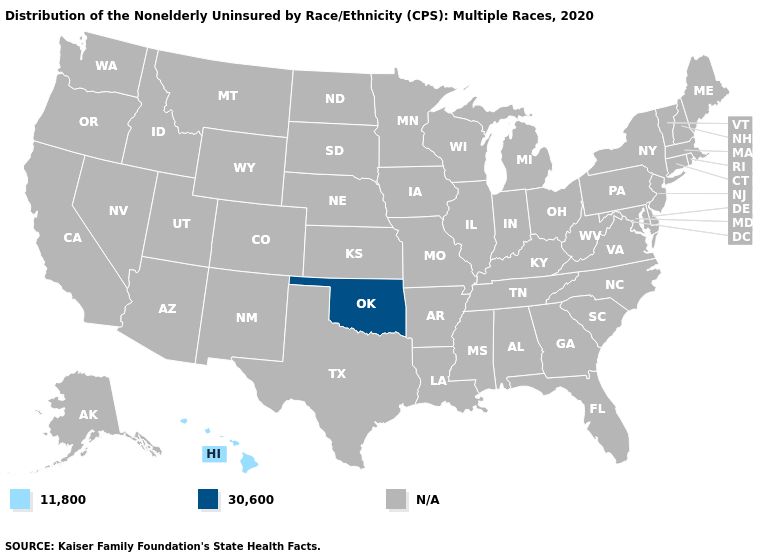Name the states that have a value in the range 30,600?
Give a very brief answer. Oklahoma. Does the map have missing data?
Concise answer only. Yes. Name the states that have a value in the range 30,600?
Concise answer only. Oklahoma. Name the states that have a value in the range 30,600?
Be succinct. Oklahoma. Name the states that have a value in the range 11,800?
Be succinct. Hawaii. Name the states that have a value in the range 30,600?
Write a very short answer. Oklahoma. Name the states that have a value in the range 30,600?
Quick response, please. Oklahoma. Name the states that have a value in the range N/A?
Answer briefly. Alabama, Alaska, Arizona, Arkansas, California, Colorado, Connecticut, Delaware, Florida, Georgia, Idaho, Illinois, Indiana, Iowa, Kansas, Kentucky, Louisiana, Maine, Maryland, Massachusetts, Michigan, Minnesota, Mississippi, Missouri, Montana, Nebraska, Nevada, New Hampshire, New Jersey, New Mexico, New York, North Carolina, North Dakota, Ohio, Oregon, Pennsylvania, Rhode Island, South Carolina, South Dakota, Tennessee, Texas, Utah, Vermont, Virginia, Washington, West Virginia, Wisconsin, Wyoming. Name the states that have a value in the range 30,600?
Concise answer only. Oklahoma. Does Hawaii have the lowest value in the USA?
Give a very brief answer. Yes. 